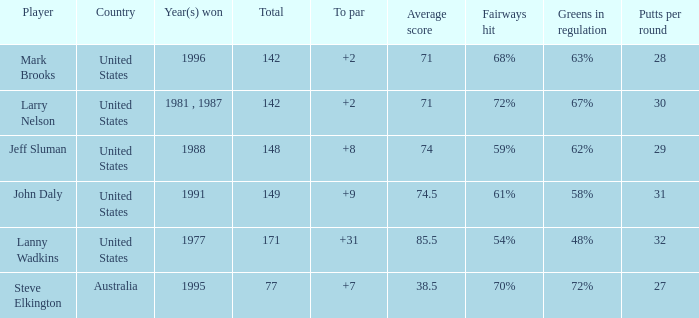Name the Total of australia and a To par smaller than 7? None. 